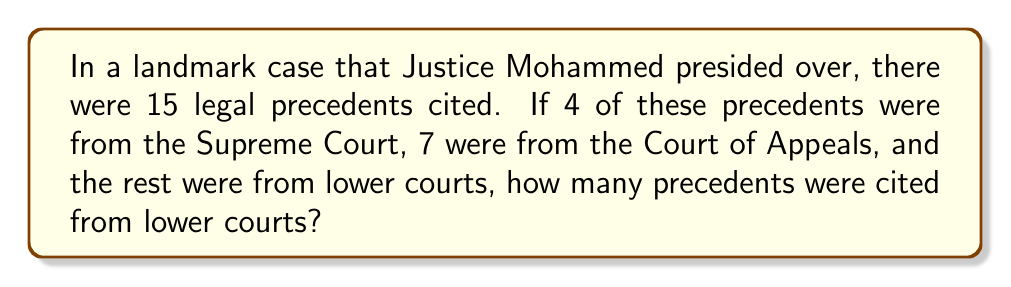Can you answer this question? To solve this problem, we'll follow these steps:

1. Identify the total number of precedents cited:
   $$ \text{Total precedents} = 15 $$

2. Sum up the number of precedents from known courts:
   $$ \text{Supreme Court precedents} = 4 $$
   $$ \text{Court of Appeals precedents} = 7 $$
   $$ \text{Known precedents} = 4 + 7 = 11 $$

3. Calculate the number of precedents from lower courts:
   $$ \text{Lower court precedents} = \text{Total precedents} - \text{Known precedents} $$
   $$ \text{Lower court precedents} = 15 - 11 = 4 $$

Therefore, 4 precedents were cited from lower courts in this landmark case.
Answer: 4 